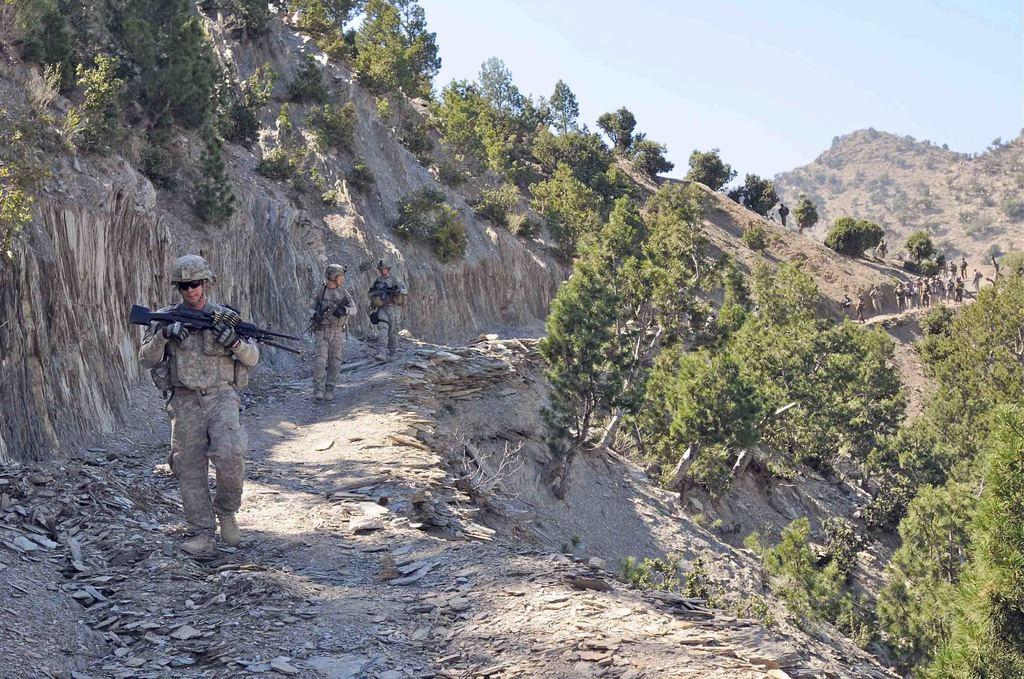What can be seen on the left side of the image? There are men in the image, and they are on the left side. What are the men holding in the image? The men are holding weapons in the image. What type of natural landscape is visible in the image? There are trees on a hill in the image. What is visible at the top of the image? The sky is visible at the top of the image, and it is sunny. What type of porter is carrying things on the hill in the image? There is no porter carrying things on the hill in the image. What type of plants can be seen growing on the men in the image? There are no plants growing on the men in the image. 